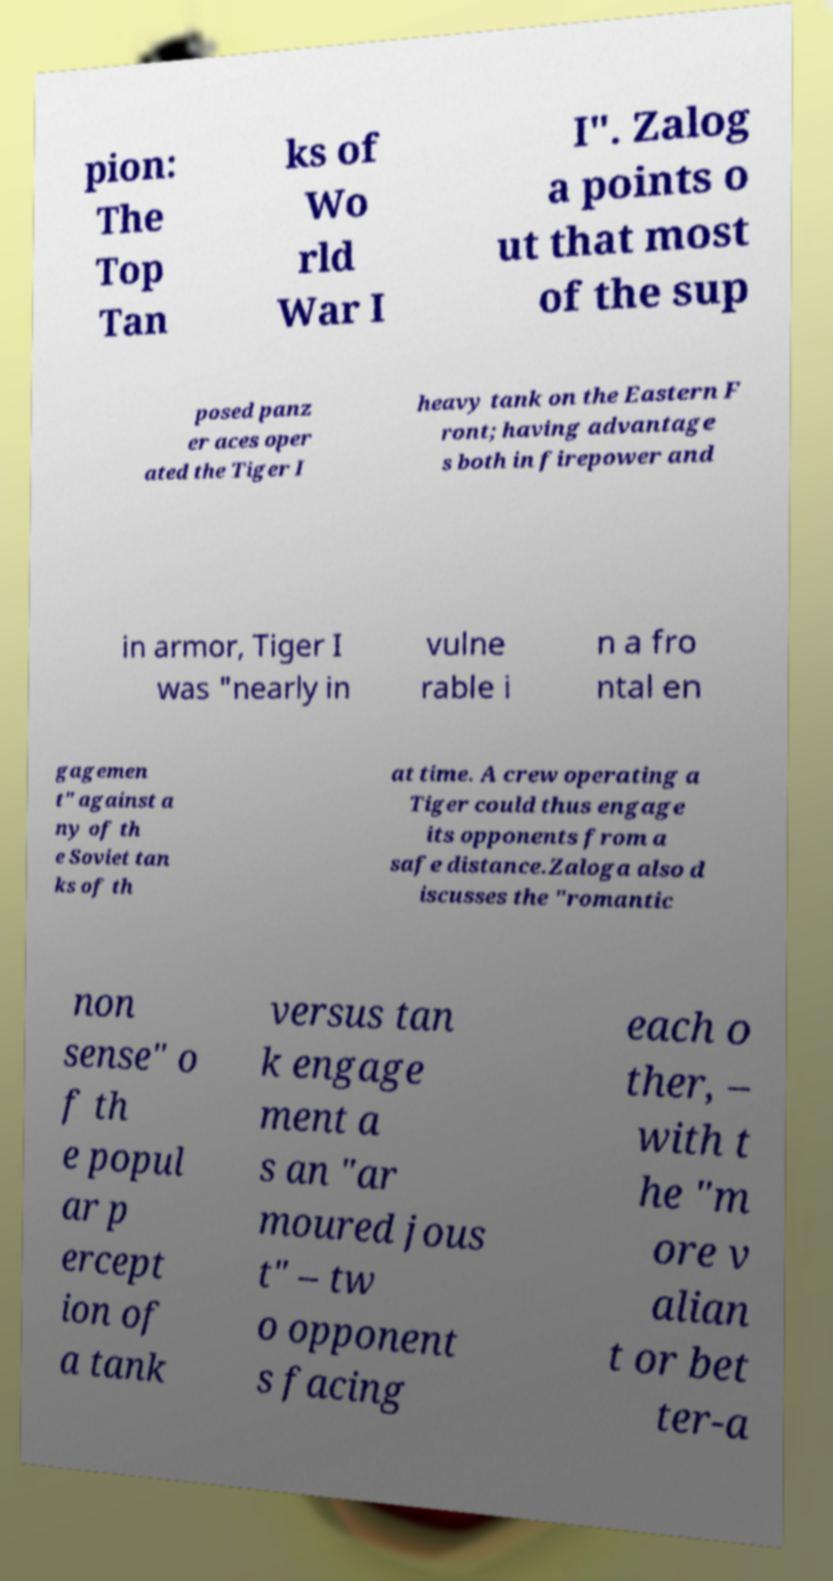Can you accurately transcribe the text from the provided image for me? pion: The Top Tan ks of Wo rld War I I". Zalog a points o ut that most of the sup posed panz er aces oper ated the Tiger I heavy tank on the Eastern F ront; having advantage s both in firepower and in armor, Tiger I was "nearly in vulne rable i n a fro ntal en gagemen t" against a ny of th e Soviet tan ks of th at time. A crew operating a Tiger could thus engage its opponents from a safe distance.Zaloga also d iscusses the "romantic non sense" o f th e popul ar p ercept ion of a tank versus tan k engage ment a s an "ar moured jous t" – tw o opponent s facing each o ther, – with t he "m ore v alian t or bet ter-a 